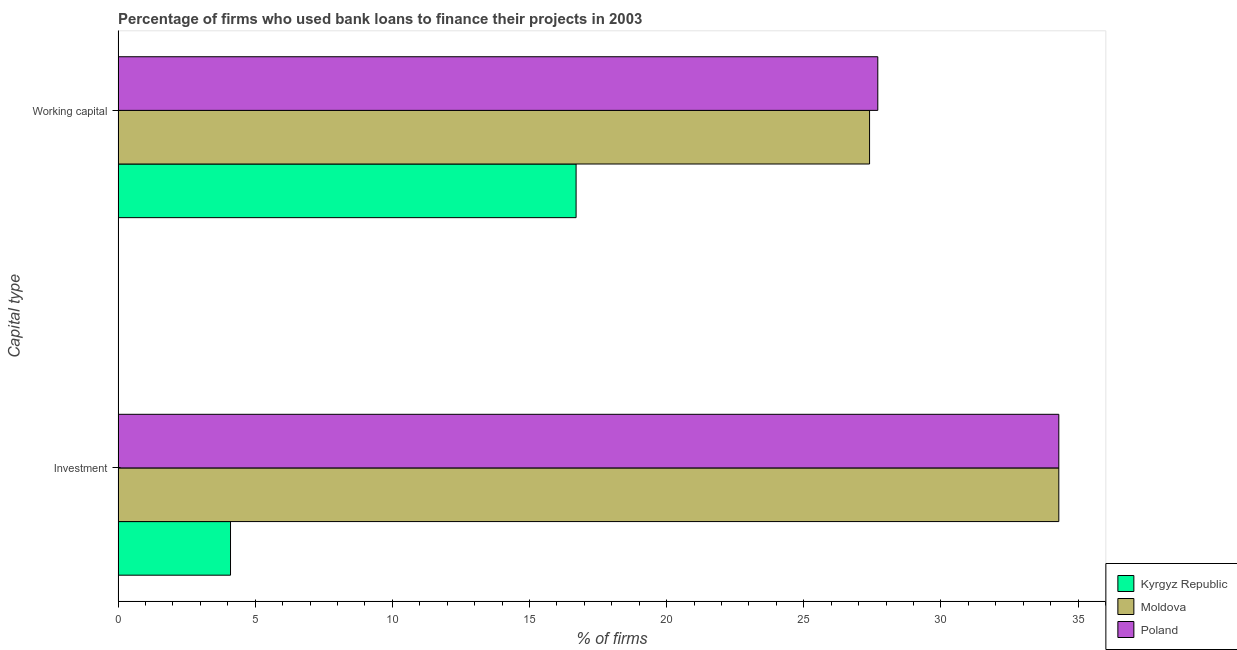How many different coloured bars are there?
Ensure brevity in your answer.  3. How many groups of bars are there?
Ensure brevity in your answer.  2. Are the number of bars per tick equal to the number of legend labels?
Your answer should be compact. Yes. Are the number of bars on each tick of the Y-axis equal?
Ensure brevity in your answer.  Yes. How many bars are there on the 2nd tick from the top?
Offer a terse response. 3. What is the label of the 2nd group of bars from the top?
Your answer should be very brief. Investment. Across all countries, what is the maximum percentage of firms using banks to finance investment?
Provide a succinct answer. 34.3. Across all countries, what is the minimum percentage of firms using banks to finance investment?
Make the answer very short. 4.1. In which country was the percentage of firms using banks to finance investment maximum?
Provide a short and direct response. Moldova. In which country was the percentage of firms using banks to finance working capital minimum?
Provide a short and direct response. Kyrgyz Republic. What is the total percentage of firms using banks to finance working capital in the graph?
Your answer should be compact. 71.8. What is the difference between the percentage of firms using banks to finance working capital in Kyrgyz Republic and that in Poland?
Provide a succinct answer. -11. What is the difference between the percentage of firms using banks to finance working capital in Moldova and the percentage of firms using banks to finance investment in Kyrgyz Republic?
Your response must be concise. 23.3. What is the average percentage of firms using banks to finance working capital per country?
Give a very brief answer. 23.93. What is the ratio of the percentage of firms using banks to finance working capital in Moldova to that in Poland?
Your response must be concise. 0.99. Is the percentage of firms using banks to finance investment in Poland less than that in Kyrgyz Republic?
Offer a terse response. No. In how many countries, is the percentage of firms using banks to finance investment greater than the average percentage of firms using banks to finance investment taken over all countries?
Ensure brevity in your answer.  2. What does the 1st bar from the top in Working capital represents?
Make the answer very short. Poland. How many bars are there?
Keep it short and to the point. 6. Are all the bars in the graph horizontal?
Ensure brevity in your answer.  Yes. What is the difference between two consecutive major ticks on the X-axis?
Provide a short and direct response. 5. Are the values on the major ticks of X-axis written in scientific E-notation?
Provide a succinct answer. No. Does the graph contain grids?
Offer a terse response. No. How many legend labels are there?
Your answer should be compact. 3. How are the legend labels stacked?
Make the answer very short. Vertical. What is the title of the graph?
Offer a very short reply. Percentage of firms who used bank loans to finance their projects in 2003. Does "St. Vincent and the Grenadines" appear as one of the legend labels in the graph?
Make the answer very short. No. What is the label or title of the X-axis?
Ensure brevity in your answer.  % of firms. What is the label or title of the Y-axis?
Keep it short and to the point. Capital type. What is the % of firms in Moldova in Investment?
Make the answer very short. 34.3. What is the % of firms of Poland in Investment?
Provide a short and direct response. 34.3. What is the % of firms of Moldova in Working capital?
Offer a very short reply. 27.4. What is the % of firms of Poland in Working capital?
Your response must be concise. 27.7. Across all Capital type, what is the maximum % of firms of Kyrgyz Republic?
Keep it short and to the point. 16.7. Across all Capital type, what is the maximum % of firms of Moldova?
Make the answer very short. 34.3. Across all Capital type, what is the maximum % of firms in Poland?
Offer a terse response. 34.3. Across all Capital type, what is the minimum % of firms of Kyrgyz Republic?
Provide a succinct answer. 4.1. Across all Capital type, what is the minimum % of firms in Moldova?
Your answer should be compact. 27.4. Across all Capital type, what is the minimum % of firms in Poland?
Your answer should be compact. 27.7. What is the total % of firms of Kyrgyz Republic in the graph?
Provide a short and direct response. 20.8. What is the total % of firms of Moldova in the graph?
Keep it short and to the point. 61.7. What is the difference between the % of firms of Kyrgyz Republic in Investment and that in Working capital?
Make the answer very short. -12.6. What is the difference between the % of firms in Moldova in Investment and that in Working capital?
Make the answer very short. 6.9. What is the difference between the % of firms in Poland in Investment and that in Working capital?
Your answer should be very brief. 6.6. What is the difference between the % of firms in Kyrgyz Republic in Investment and the % of firms in Moldova in Working capital?
Your response must be concise. -23.3. What is the difference between the % of firms of Kyrgyz Republic in Investment and the % of firms of Poland in Working capital?
Keep it short and to the point. -23.6. What is the difference between the % of firms of Moldova in Investment and the % of firms of Poland in Working capital?
Provide a short and direct response. 6.6. What is the average % of firms in Moldova per Capital type?
Your response must be concise. 30.85. What is the average % of firms of Poland per Capital type?
Provide a short and direct response. 31. What is the difference between the % of firms in Kyrgyz Republic and % of firms in Moldova in Investment?
Provide a succinct answer. -30.2. What is the difference between the % of firms of Kyrgyz Republic and % of firms of Poland in Investment?
Keep it short and to the point. -30.2. What is the difference between the % of firms in Moldova and % of firms in Poland in Working capital?
Your answer should be very brief. -0.3. What is the ratio of the % of firms of Kyrgyz Republic in Investment to that in Working capital?
Keep it short and to the point. 0.25. What is the ratio of the % of firms of Moldova in Investment to that in Working capital?
Provide a succinct answer. 1.25. What is the ratio of the % of firms in Poland in Investment to that in Working capital?
Offer a terse response. 1.24. What is the difference between the highest and the second highest % of firms in Kyrgyz Republic?
Your answer should be very brief. 12.6. What is the difference between the highest and the second highest % of firms of Poland?
Provide a short and direct response. 6.6. 